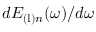<formula> <loc_0><loc_0><loc_500><loc_500>d E _ { ( l ) n } ( \omega ) / d \omega</formula> 